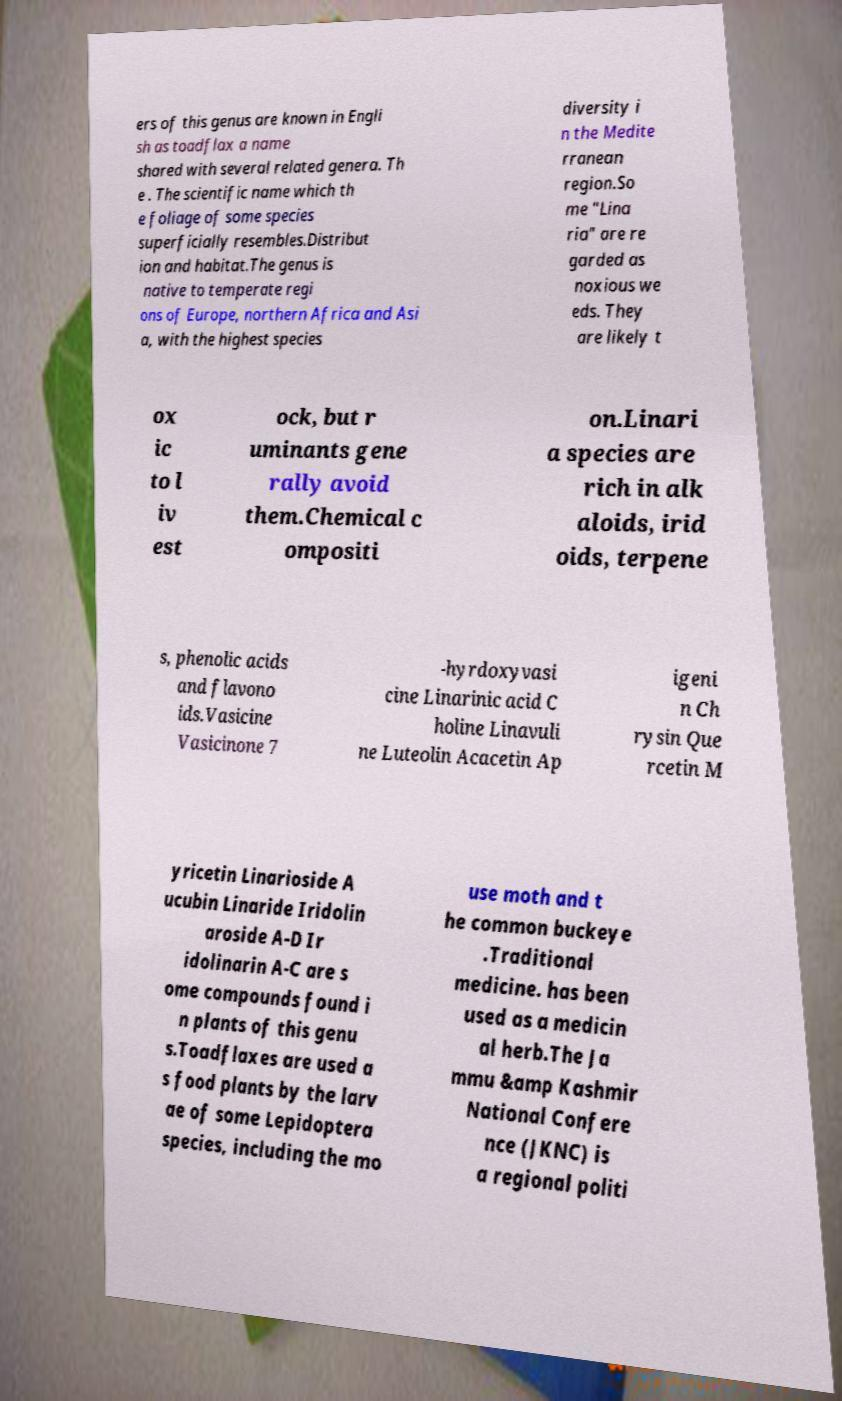For documentation purposes, I need the text within this image transcribed. Could you provide that? ers of this genus are known in Engli sh as toadflax a name shared with several related genera. Th e . The scientific name which th e foliage of some species superficially resembles.Distribut ion and habitat.The genus is native to temperate regi ons of Europe, northern Africa and Asi a, with the highest species diversity i n the Medite rranean region.So me "Lina ria" are re garded as noxious we eds. They are likely t ox ic to l iv est ock, but r uminants gene rally avoid them.Chemical c ompositi on.Linari a species are rich in alk aloids, irid oids, terpene s, phenolic acids and flavono ids.Vasicine Vasicinone 7 -hyrdoxyvasi cine Linarinic acid C holine Linavuli ne Luteolin Acacetin Ap igeni n Ch rysin Que rcetin M yricetin Linarioside A ucubin Linaride Iridolin aroside A-D Ir idolinarin A-C are s ome compounds found i n plants of this genu s.Toadflaxes are used a s food plants by the larv ae of some Lepidoptera species, including the mo use moth and t he common buckeye .Traditional medicine. has been used as a medicin al herb.The Ja mmu &amp Kashmir National Confere nce (JKNC) is a regional politi 